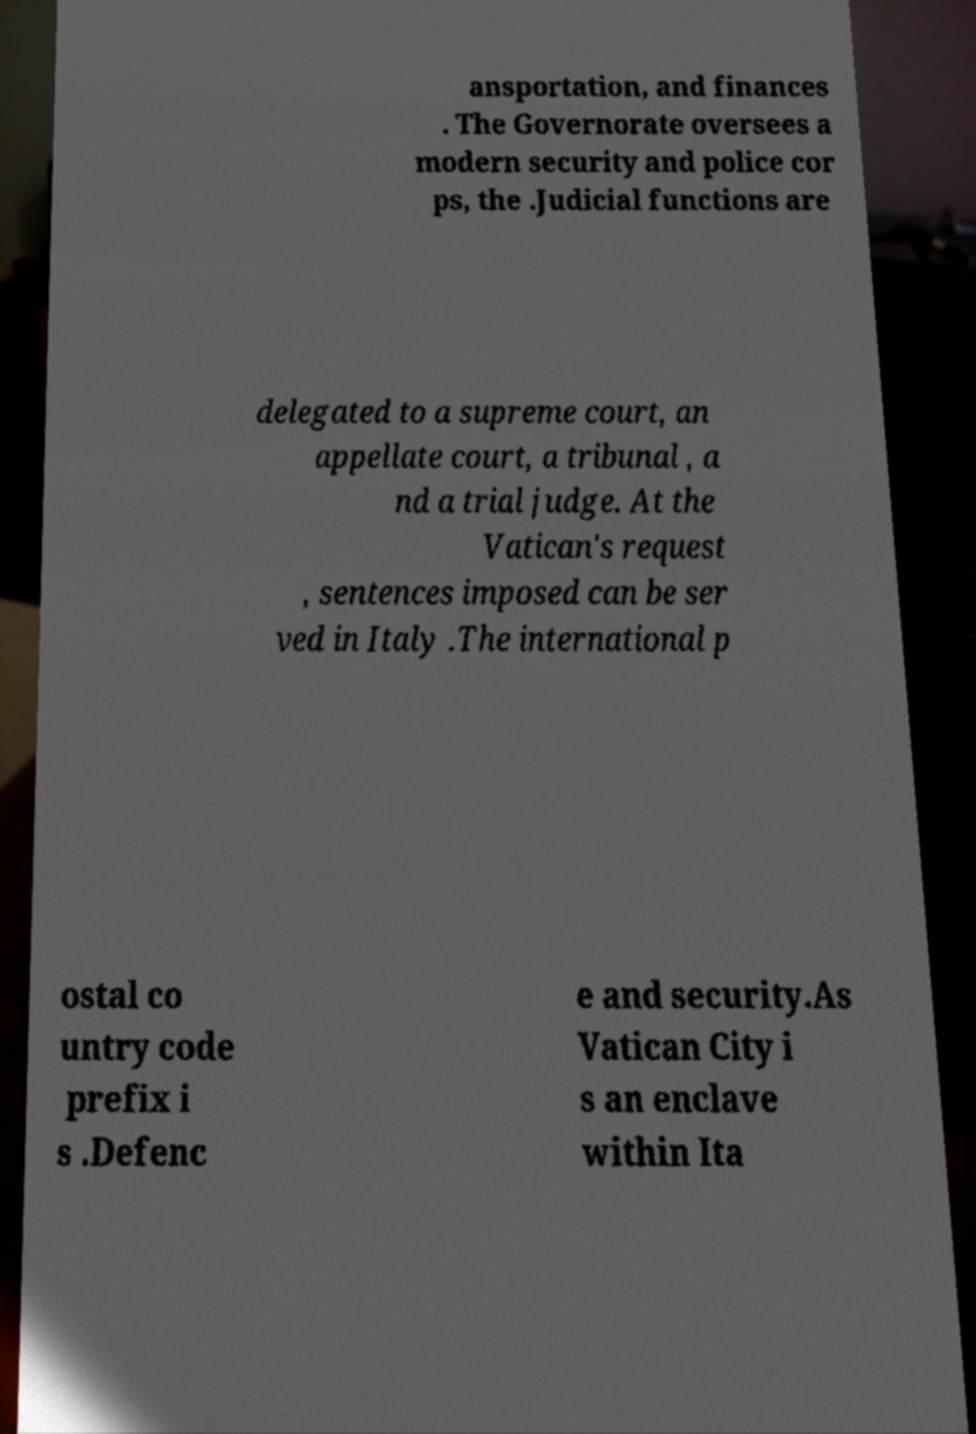Please read and relay the text visible in this image. What does it say? ansportation, and finances . The Governorate oversees a modern security and police cor ps, the .Judicial functions are delegated to a supreme court, an appellate court, a tribunal , a nd a trial judge. At the Vatican's request , sentences imposed can be ser ved in Italy .The international p ostal co untry code prefix i s .Defenc e and security.As Vatican City i s an enclave within Ita 